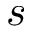Convert formula to latex. <formula><loc_0><loc_0><loc_500><loc_500>s</formula> 